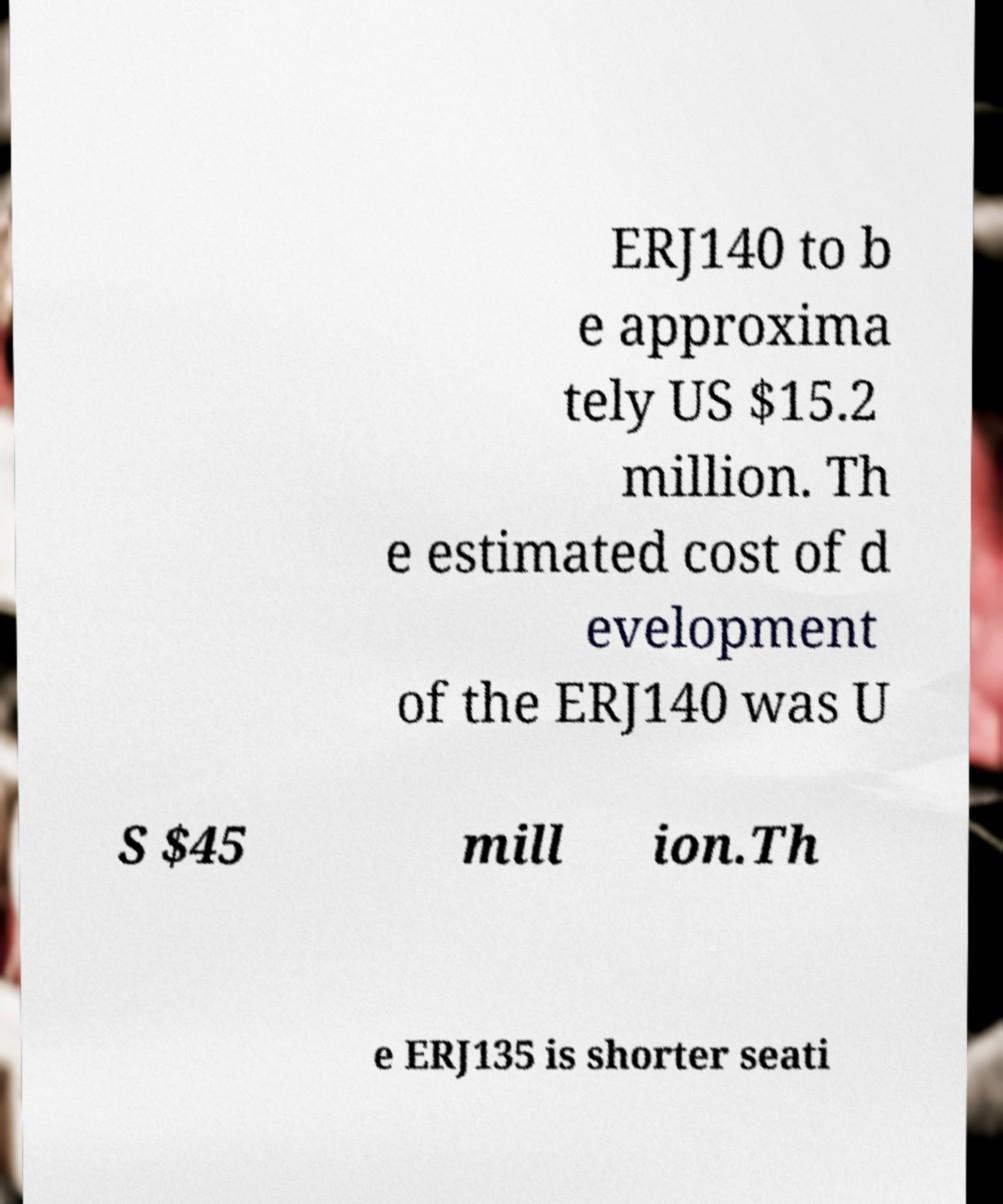There's text embedded in this image that I need extracted. Can you transcribe it verbatim? ERJ140 to b e approxima tely US $15.2 million. Th e estimated cost of d evelopment of the ERJ140 was U S $45 mill ion.Th e ERJ135 is shorter seati 